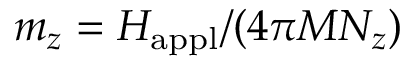<formula> <loc_0><loc_0><loc_500><loc_500>m _ { z } = H _ { a p p l } / ( 4 \pi M N _ { z } )</formula> 